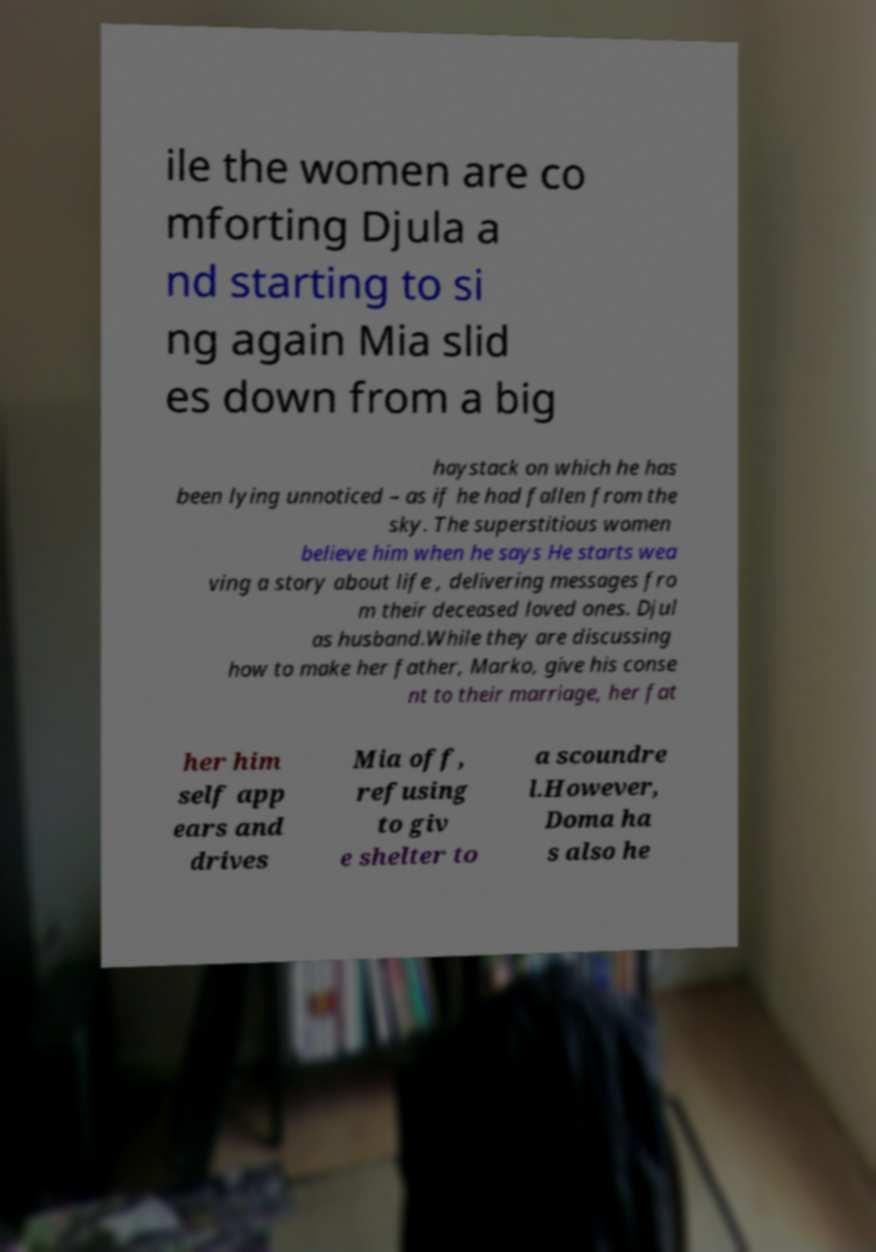For documentation purposes, I need the text within this image transcribed. Could you provide that? ile the women are co mforting Djula a nd starting to si ng again Mia slid es down from a big haystack on which he has been lying unnoticed – as if he had fallen from the sky. The superstitious women believe him when he says He starts wea ving a story about life , delivering messages fro m their deceased loved ones. Djul as husband.While they are discussing how to make her father, Marko, give his conse nt to their marriage, her fat her him self app ears and drives Mia off, refusing to giv e shelter to a scoundre l.However, Doma ha s also he 